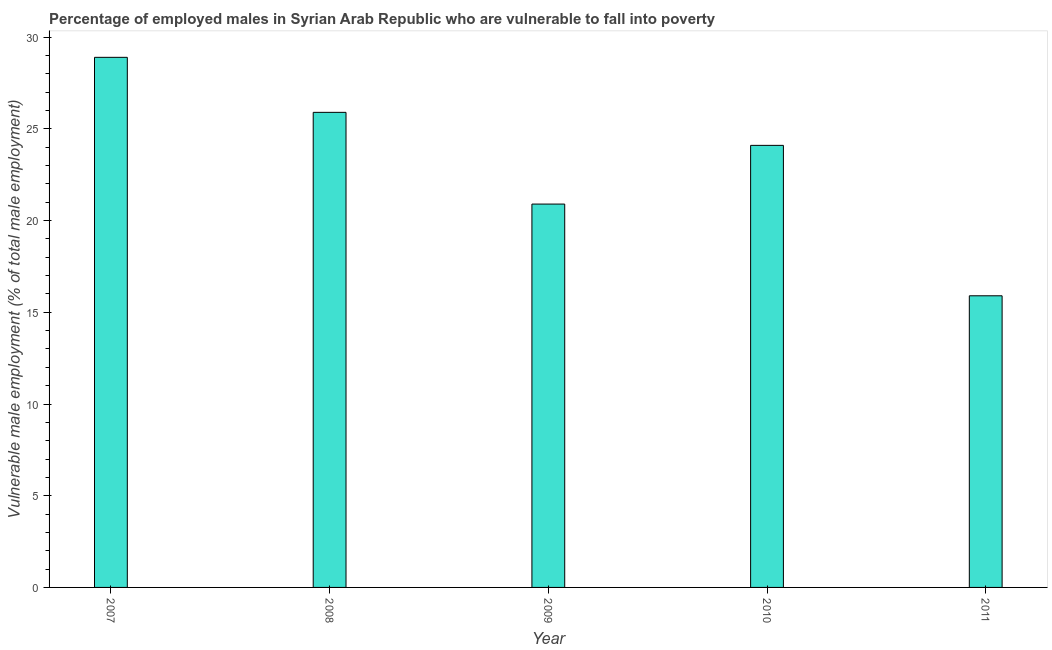Does the graph contain grids?
Keep it short and to the point. No. What is the title of the graph?
Give a very brief answer. Percentage of employed males in Syrian Arab Republic who are vulnerable to fall into poverty. What is the label or title of the X-axis?
Provide a short and direct response. Year. What is the label or title of the Y-axis?
Provide a succinct answer. Vulnerable male employment (% of total male employment). What is the percentage of employed males who are vulnerable to fall into poverty in 2010?
Make the answer very short. 24.1. Across all years, what is the maximum percentage of employed males who are vulnerable to fall into poverty?
Provide a short and direct response. 28.9. Across all years, what is the minimum percentage of employed males who are vulnerable to fall into poverty?
Your answer should be compact. 15.9. In which year was the percentage of employed males who are vulnerable to fall into poverty maximum?
Ensure brevity in your answer.  2007. In which year was the percentage of employed males who are vulnerable to fall into poverty minimum?
Provide a succinct answer. 2011. What is the sum of the percentage of employed males who are vulnerable to fall into poverty?
Give a very brief answer. 115.7. What is the difference between the percentage of employed males who are vulnerable to fall into poverty in 2007 and 2010?
Ensure brevity in your answer.  4.8. What is the average percentage of employed males who are vulnerable to fall into poverty per year?
Provide a short and direct response. 23.14. What is the median percentage of employed males who are vulnerable to fall into poverty?
Offer a very short reply. 24.1. Do a majority of the years between 2008 and 2011 (inclusive) have percentage of employed males who are vulnerable to fall into poverty greater than 13 %?
Offer a very short reply. Yes. What is the ratio of the percentage of employed males who are vulnerable to fall into poverty in 2010 to that in 2011?
Your answer should be compact. 1.52. Is the percentage of employed males who are vulnerable to fall into poverty in 2007 less than that in 2010?
Your answer should be compact. No. What is the difference between the highest and the second highest percentage of employed males who are vulnerable to fall into poverty?
Your response must be concise. 3. Is the sum of the percentage of employed males who are vulnerable to fall into poverty in 2009 and 2011 greater than the maximum percentage of employed males who are vulnerable to fall into poverty across all years?
Your answer should be compact. Yes. What is the difference between the highest and the lowest percentage of employed males who are vulnerable to fall into poverty?
Your response must be concise. 13. In how many years, is the percentage of employed males who are vulnerable to fall into poverty greater than the average percentage of employed males who are vulnerable to fall into poverty taken over all years?
Your answer should be compact. 3. How many bars are there?
Make the answer very short. 5. Are all the bars in the graph horizontal?
Your answer should be very brief. No. Are the values on the major ticks of Y-axis written in scientific E-notation?
Make the answer very short. No. What is the Vulnerable male employment (% of total male employment) of 2007?
Keep it short and to the point. 28.9. What is the Vulnerable male employment (% of total male employment) of 2008?
Make the answer very short. 25.9. What is the Vulnerable male employment (% of total male employment) of 2009?
Your answer should be compact. 20.9. What is the Vulnerable male employment (% of total male employment) of 2010?
Offer a terse response. 24.1. What is the Vulnerable male employment (% of total male employment) of 2011?
Keep it short and to the point. 15.9. What is the difference between the Vulnerable male employment (% of total male employment) in 2007 and 2008?
Provide a short and direct response. 3. What is the difference between the Vulnerable male employment (% of total male employment) in 2007 and 2009?
Ensure brevity in your answer.  8. What is the difference between the Vulnerable male employment (% of total male employment) in 2007 and 2010?
Provide a short and direct response. 4.8. What is the difference between the Vulnerable male employment (% of total male employment) in 2008 and 2009?
Offer a very short reply. 5. What is the difference between the Vulnerable male employment (% of total male employment) in 2008 and 2010?
Ensure brevity in your answer.  1.8. What is the difference between the Vulnerable male employment (% of total male employment) in 2008 and 2011?
Make the answer very short. 10. What is the difference between the Vulnerable male employment (% of total male employment) in 2009 and 2011?
Ensure brevity in your answer.  5. What is the ratio of the Vulnerable male employment (% of total male employment) in 2007 to that in 2008?
Your response must be concise. 1.12. What is the ratio of the Vulnerable male employment (% of total male employment) in 2007 to that in 2009?
Provide a short and direct response. 1.38. What is the ratio of the Vulnerable male employment (% of total male employment) in 2007 to that in 2010?
Your response must be concise. 1.2. What is the ratio of the Vulnerable male employment (% of total male employment) in 2007 to that in 2011?
Provide a short and direct response. 1.82. What is the ratio of the Vulnerable male employment (% of total male employment) in 2008 to that in 2009?
Ensure brevity in your answer.  1.24. What is the ratio of the Vulnerable male employment (% of total male employment) in 2008 to that in 2010?
Your response must be concise. 1.07. What is the ratio of the Vulnerable male employment (% of total male employment) in 2008 to that in 2011?
Offer a terse response. 1.63. What is the ratio of the Vulnerable male employment (% of total male employment) in 2009 to that in 2010?
Provide a short and direct response. 0.87. What is the ratio of the Vulnerable male employment (% of total male employment) in 2009 to that in 2011?
Give a very brief answer. 1.31. What is the ratio of the Vulnerable male employment (% of total male employment) in 2010 to that in 2011?
Keep it short and to the point. 1.52. 